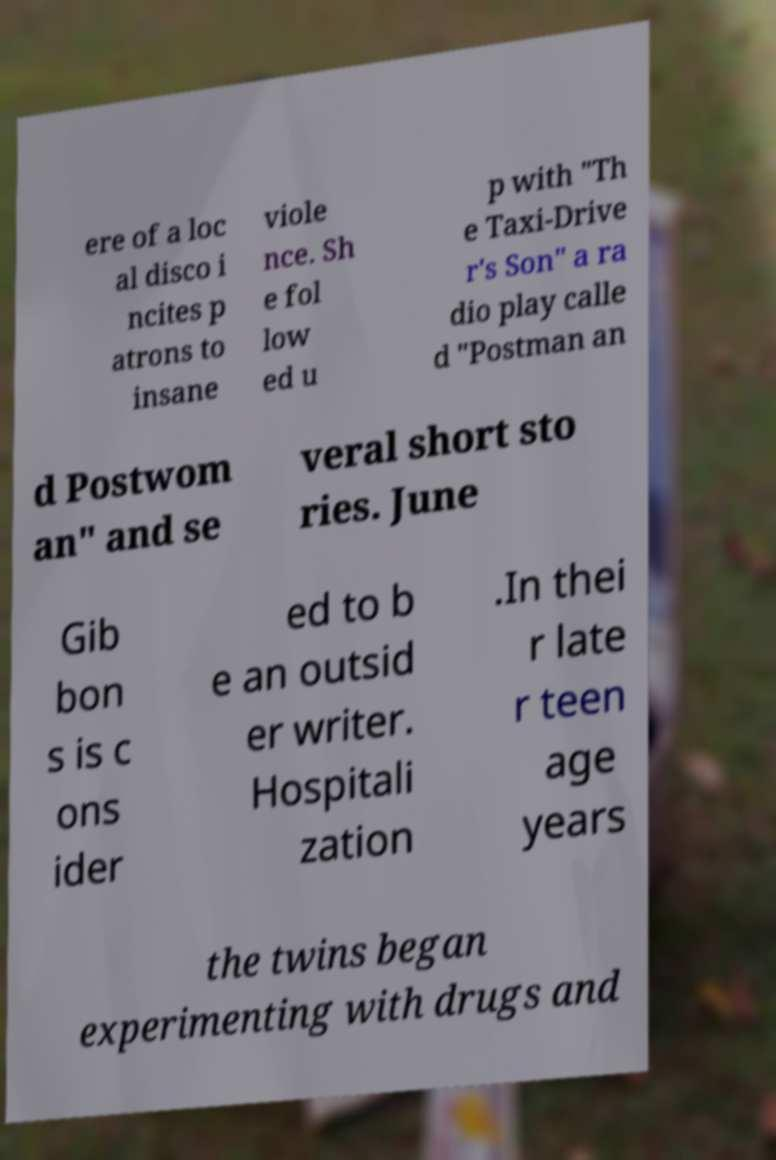Can you read and provide the text displayed in the image?This photo seems to have some interesting text. Can you extract and type it out for me? ere of a loc al disco i ncites p atrons to insane viole nce. Sh e fol low ed u p with "Th e Taxi-Drive r's Son" a ra dio play calle d "Postman an d Postwom an" and se veral short sto ries. June Gib bon s is c ons ider ed to b e an outsid er writer. Hospitali zation .In thei r late r teen age years the twins began experimenting with drugs and 